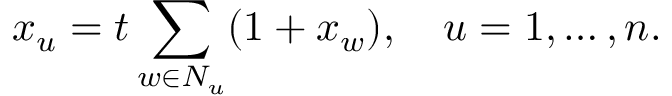Convert formula to latex. <formula><loc_0><loc_0><loc_500><loc_500>x _ { u } = t \sum _ { w \in N _ { u } } ( 1 + x _ { w } ) , \quad u = 1 , \dots , n .</formula> 